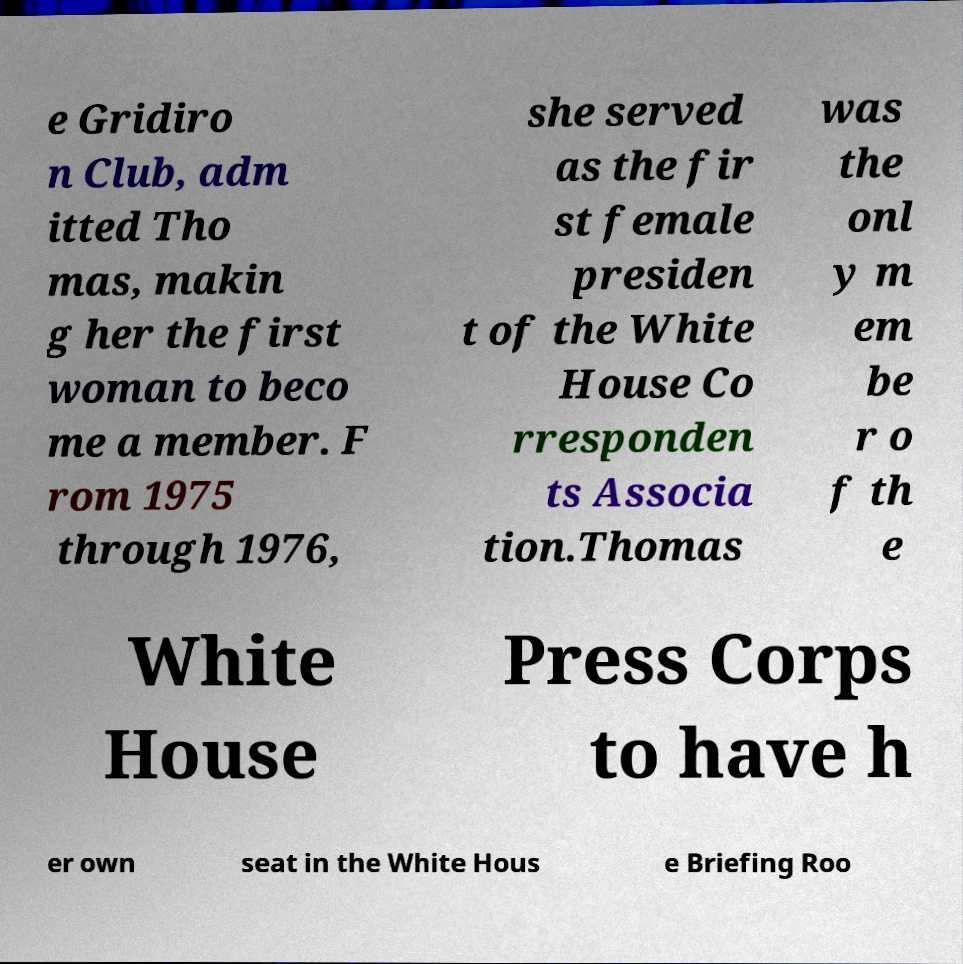There's text embedded in this image that I need extracted. Can you transcribe it verbatim? e Gridiro n Club, adm itted Tho mas, makin g her the first woman to beco me a member. F rom 1975 through 1976, she served as the fir st female presiden t of the White House Co rresponden ts Associa tion.Thomas was the onl y m em be r o f th e White House Press Corps to have h er own seat in the White Hous e Briefing Roo 